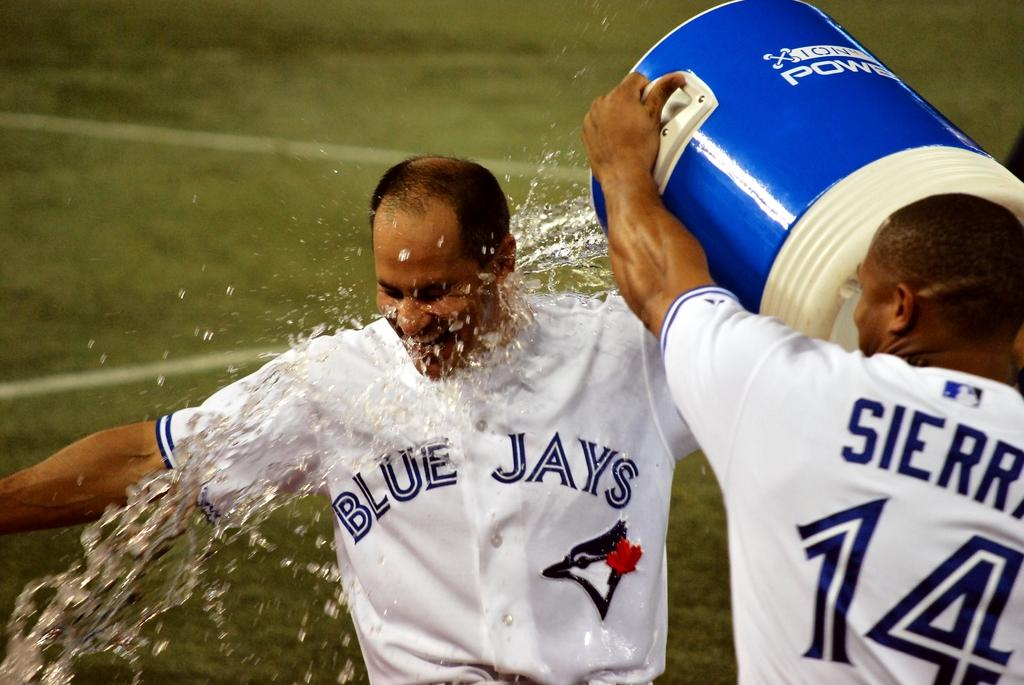<image>
Present a compact description of the photo's key features. Toronto Blue Jays Player getting Water and Gatorade dumped on for winning a game. 